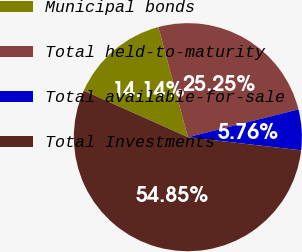Convert chart. <chart><loc_0><loc_0><loc_500><loc_500><pie_chart><fcel>Municipal bonds<fcel>Total held-to-maturity<fcel>Total available-for-sale<fcel>Total Investments<nl><fcel>14.14%<fcel>25.25%<fcel>5.76%<fcel>54.86%<nl></chart> 